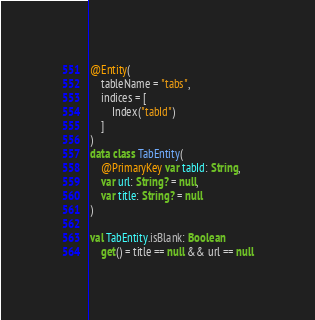Convert code to text. <code><loc_0><loc_0><loc_500><loc_500><_Kotlin_>@Entity(
    tableName = "tabs",
    indices = [
        Index("tabId")
    ]
)
data class TabEntity(
    @PrimaryKey var tabId: String,
    var url: String? = null,
    var title: String? = null
)

val TabEntity.isBlank: Boolean
    get() = title == null && url == null</code> 